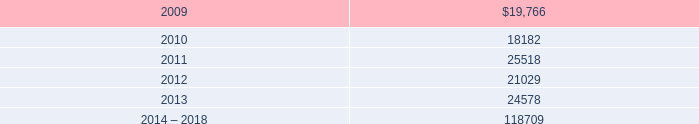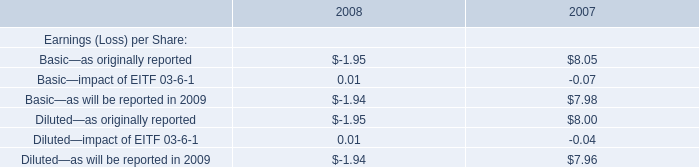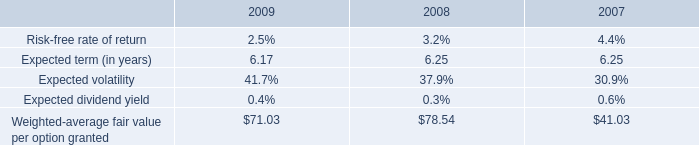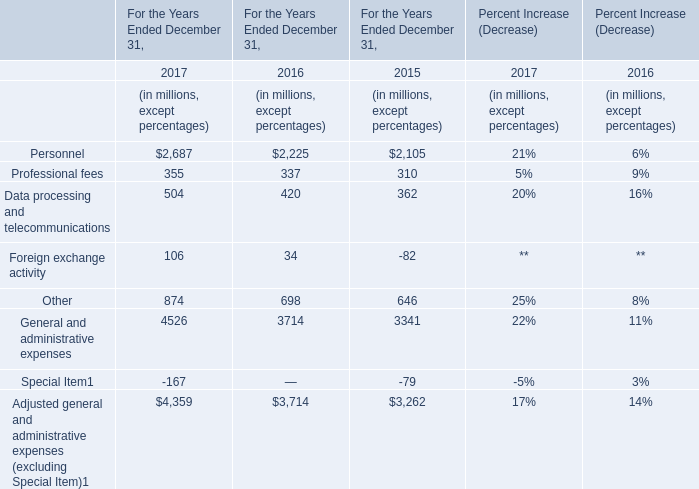How many Adjusted general and administrative expenses (excluding Special Item) exceed the average of Adjusted general and administrative expenses (excluding Special Item) in 2016? 
Computations: (3714 / 7)
Answer: 530.57143. 